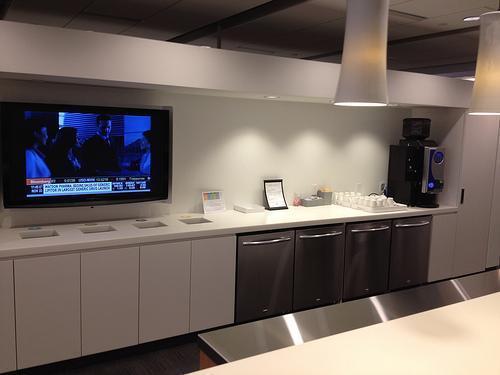How many lights can be seen?
Give a very brief answer. 2. 